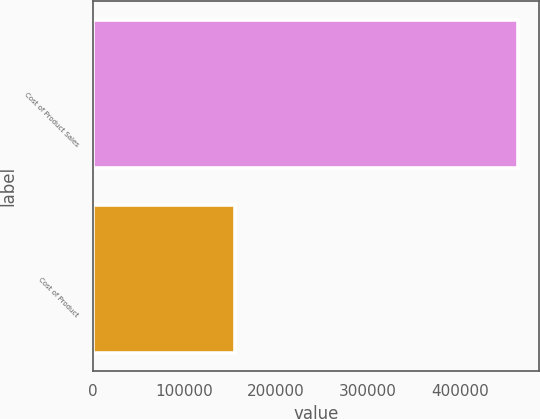Convert chart. <chart><loc_0><loc_0><loc_500><loc_500><bar_chart><fcel>Cost of Product Sales<fcel>Cost of Product<nl><fcel>463066<fcel>155519<nl></chart> 